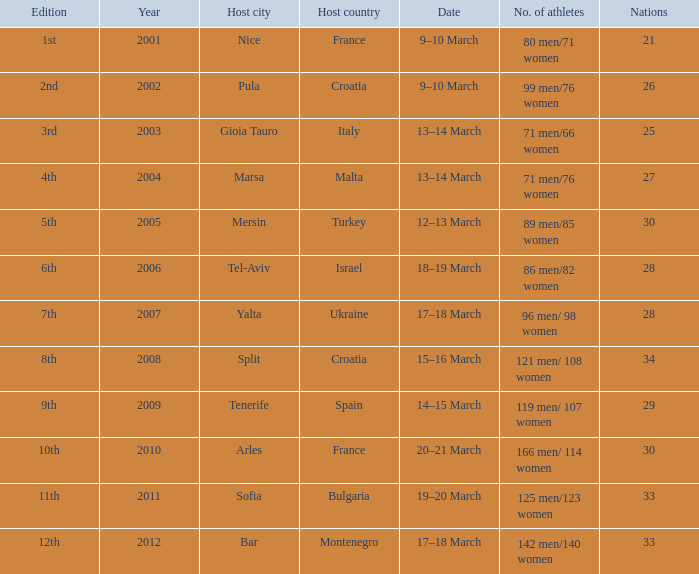What was the host city of the 8th edition in the the host country of Croatia? Split. 